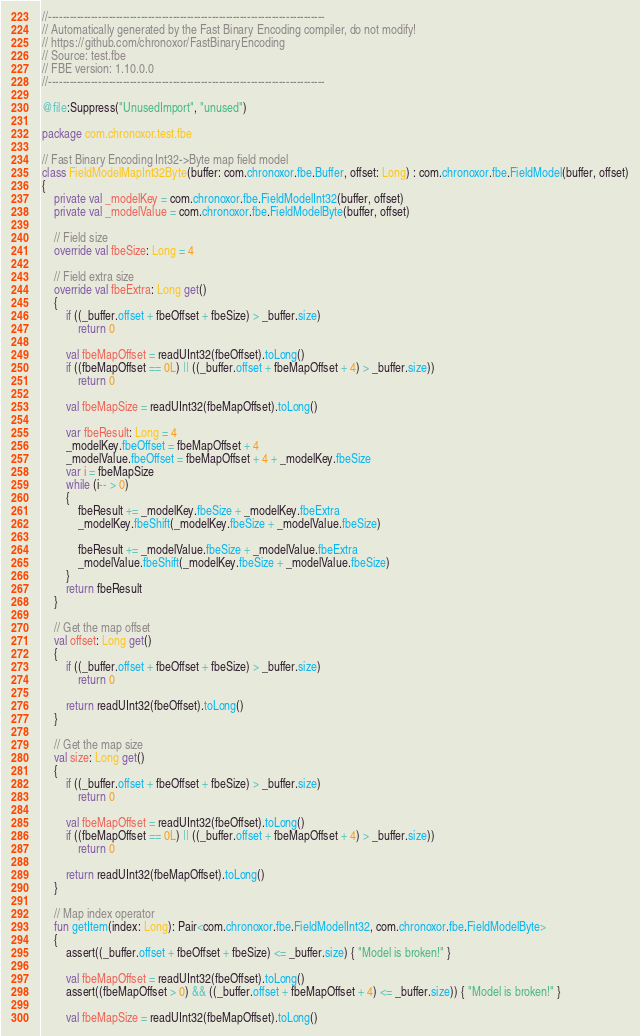<code> <loc_0><loc_0><loc_500><loc_500><_Kotlin_>//------------------------------------------------------------------------------
// Automatically generated by the Fast Binary Encoding compiler, do not modify!
// https://github.com/chronoxor/FastBinaryEncoding
// Source: test.fbe
// FBE version: 1.10.0.0
//------------------------------------------------------------------------------

@file:Suppress("UnusedImport", "unused")

package com.chronoxor.test.fbe

// Fast Binary Encoding Int32->Byte map field model
class FieldModelMapInt32Byte(buffer: com.chronoxor.fbe.Buffer, offset: Long) : com.chronoxor.fbe.FieldModel(buffer, offset)
{
    private val _modelKey = com.chronoxor.fbe.FieldModelInt32(buffer, offset)
    private val _modelValue = com.chronoxor.fbe.FieldModelByte(buffer, offset)

    // Field size
    override val fbeSize: Long = 4

    // Field extra size
    override val fbeExtra: Long get()
    {
        if ((_buffer.offset + fbeOffset + fbeSize) > _buffer.size)
            return 0

        val fbeMapOffset = readUInt32(fbeOffset).toLong()
        if ((fbeMapOffset == 0L) || ((_buffer.offset + fbeMapOffset + 4) > _buffer.size))
            return 0

        val fbeMapSize = readUInt32(fbeMapOffset).toLong()

        var fbeResult: Long = 4
        _modelKey.fbeOffset = fbeMapOffset + 4
        _modelValue.fbeOffset = fbeMapOffset + 4 + _modelKey.fbeSize
        var i = fbeMapSize
        while (i-- > 0)
        {
            fbeResult += _modelKey.fbeSize + _modelKey.fbeExtra
            _modelKey.fbeShift(_modelKey.fbeSize + _modelValue.fbeSize)

            fbeResult += _modelValue.fbeSize + _modelValue.fbeExtra
            _modelValue.fbeShift(_modelKey.fbeSize + _modelValue.fbeSize)
        }
        return fbeResult
    }

    // Get the map offset
    val offset: Long get()
    {
        if ((_buffer.offset + fbeOffset + fbeSize) > _buffer.size)
            return 0

        return readUInt32(fbeOffset).toLong()
    }

    // Get the map size
    val size: Long get()
    {
        if ((_buffer.offset + fbeOffset + fbeSize) > _buffer.size)
            return 0

        val fbeMapOffset = readUInt32(fbeOffset).toLong()
        if ((fbeMapOffset == 0L) || ((_buffer.offset + fbeMapOffset + 4) > _buffer.size))
            return 0

        return readUInt32(fbeMapOffset).toLong()
    }

    // Map index operator
    fun getItem(index: Long): Pair<com.chronoxor.fbe.FieldModelInt32, com.chronoxor.fbe.FieldModelByte>
    {
        assert((_buffer.offset + fbeOffset + fbeSize) <= _buffer.size) { "Model is broken!" }

        val fbeMapOffset = readUInt32(fbeOffset).toLong()
        assert((fbeMapOffset > 0) && ((_buffer.offset + fbeMapOffset + 4) <= _buffer.size)) { "Model is broken!" }

        val fbeMapSize = readUInt32(fbeMapOffset).toLong()</code> 